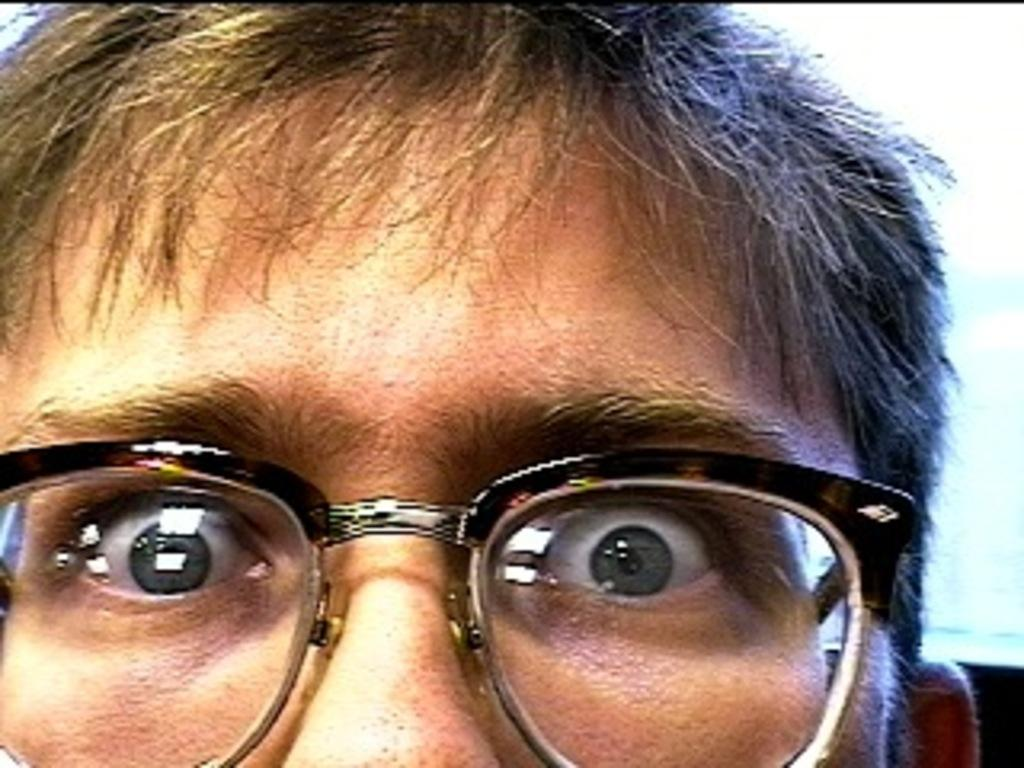What is the focus of the image? The image is zoomed, and the face of a person is visible. Can you describe the level of detail in the image? The image is zoomed, which means that the focus is on a specific area or subject, in this case, the person's face. What type of screw is being used to hold the meat together in the image? There is no screw or meat present in the image; it only shows the face of a person. 